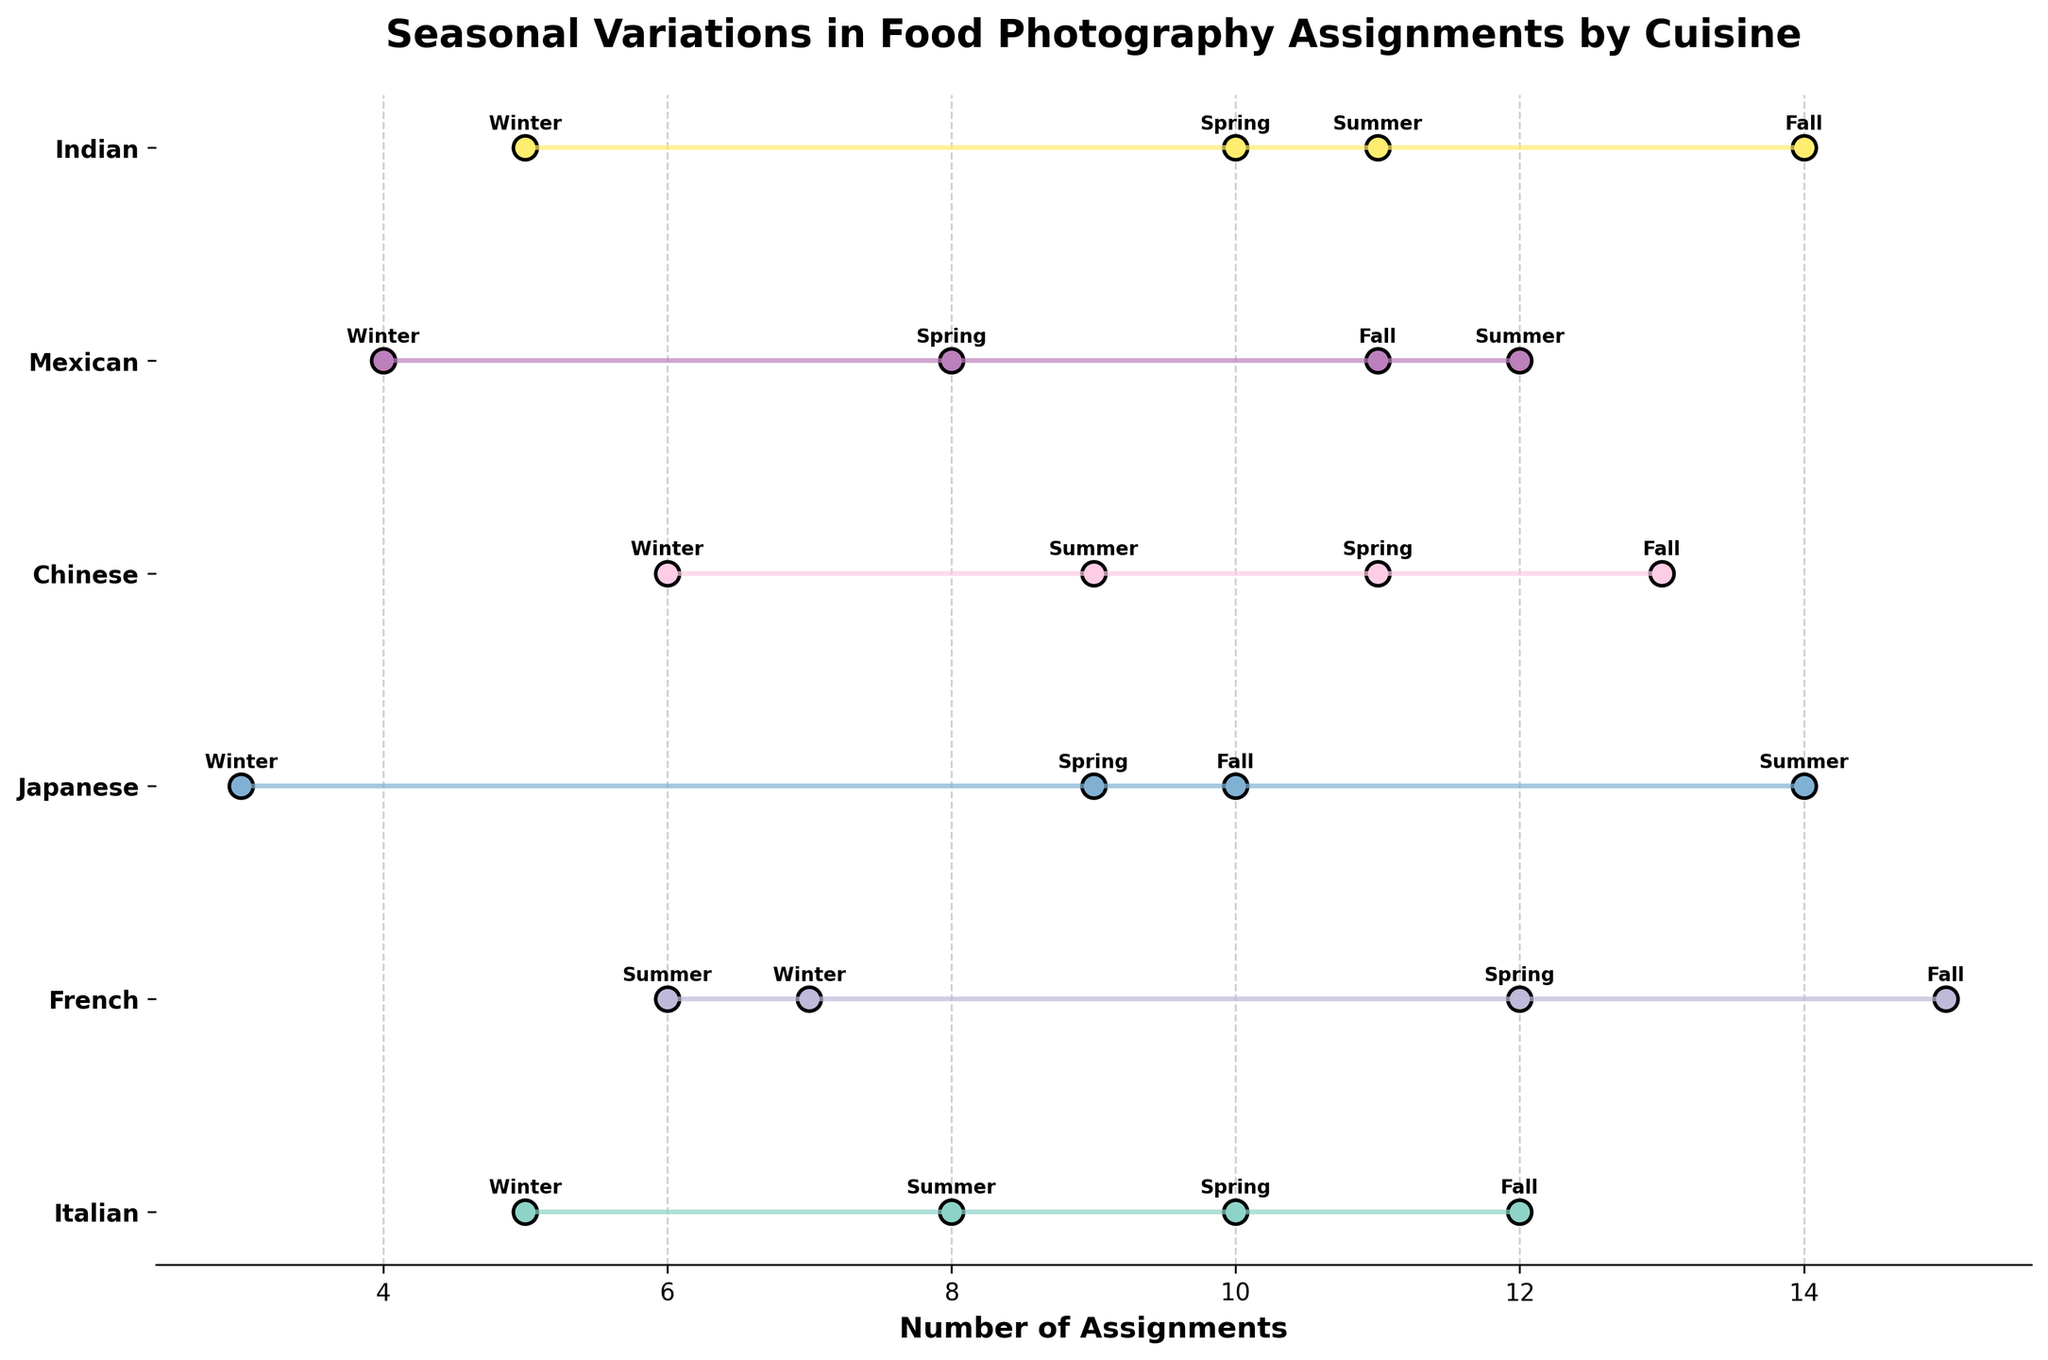What is the title of the plot? The title is always located at the top of the chart, often in bold and larger font. The title reads 'Seasonal Variations in Food Photography Assignments by Cuisine'.
Answer: Seasonal Variations in Food Photography Assignments by Cuisine Which cuisine has the most assignments in Winter? Look at the 'Winter' labels and identify the longest horizontal bar or the highest dot along the y-axis for Winter. The 'French' cuisine has the longest bar or the highest dot at 'Winter', which is at 7 assignments.
Answer: French How many more assignments does French have in Fall compared to Japanese in Winter? Identify the assignments in Fall for French (which is 15) and in Winter for Japanese (which is 3), then calculate the difference: 15 - 3 = 12.
Answer: 12 Which season has the highest number of assignments for Japanese cuisine? Find the dots for each season in Japanese cuisine and identify the highest value. Summer season has the highest at 14 assignments.
Answer: Summer What is the average number of assignments for Italian cuisine across all seasons? Collect the number of assignments for Italian (5, 10, 8, 12), sum them up (5 + 10 + 8 + 12 = 35) and divide by the number of seasons (4): 35 / 4 = 8.75.
Answer: 8.75 Which cuisine shows the largest variation in the number of assignments across seasons? Look at the longest range between the minimum and maximum number of assignments for each cuisine. French shows the widest span, from 6 (Summer) to 15 (Fall).
Answer: French How many cuisines have their highest number of assignments during Fall? Check the highest assignment number for each cuisine and see which ones are in the Fall. Italian, French, Chinese, Indian all have their highest in Fall.
Answer: 4 What is the difference in the number of assignments between the highest and lowest season for Indian cuisine? Identify the highest (Fall, 14) and lowest (Winter, 5) assignments for Indian, then find the difference: 14 - 5 = 9.
Answer: 9 Which cuisine has the least variation in their assignments across seasons? Look at the shortest range between the minimum and maximum number of assignments for each cuisine. Italian has a span from 5 (Winter) to 12 (Fall), which is the smallest.
Answer: Italian 